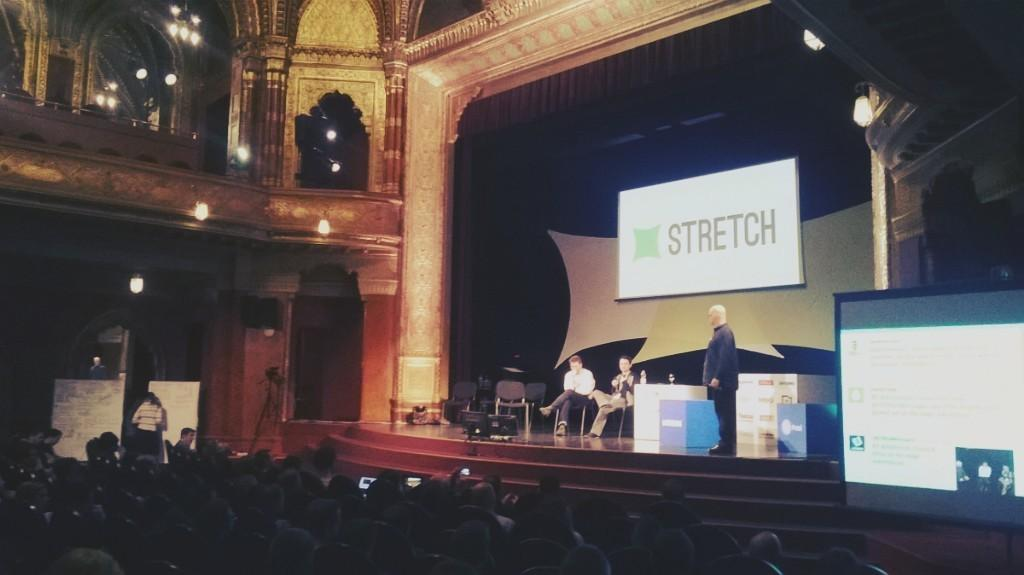<image>
Describe the image concisely. A projector displaying the word STRETCH to an audience of people on a stage. 